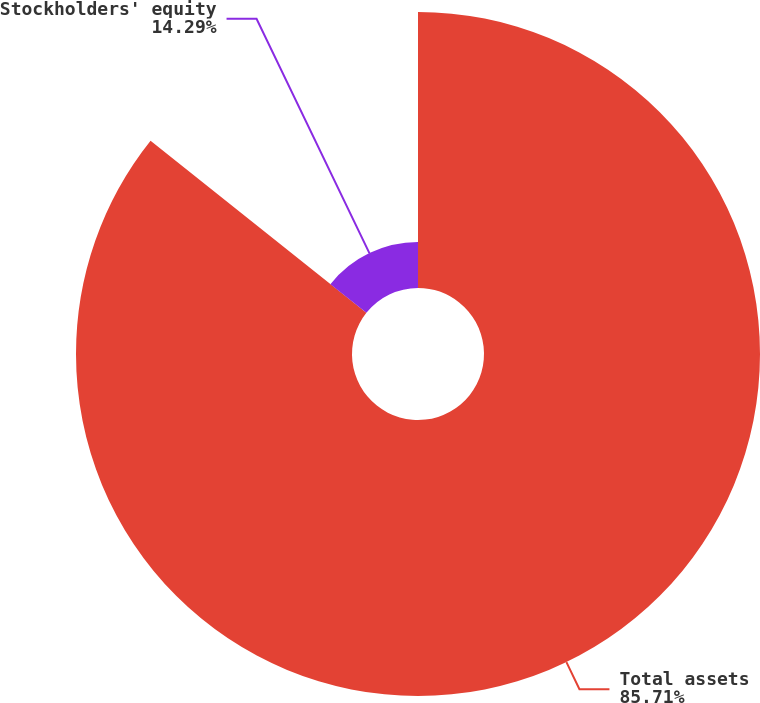Convert chart. <chart><loc_0><loc_0><loc_500><loc_500><pie_chart><fcel>Total assets<fcel>Stockholders' equity<nl><fcel>85.71%<fcel>14.29%<nl></chart> 